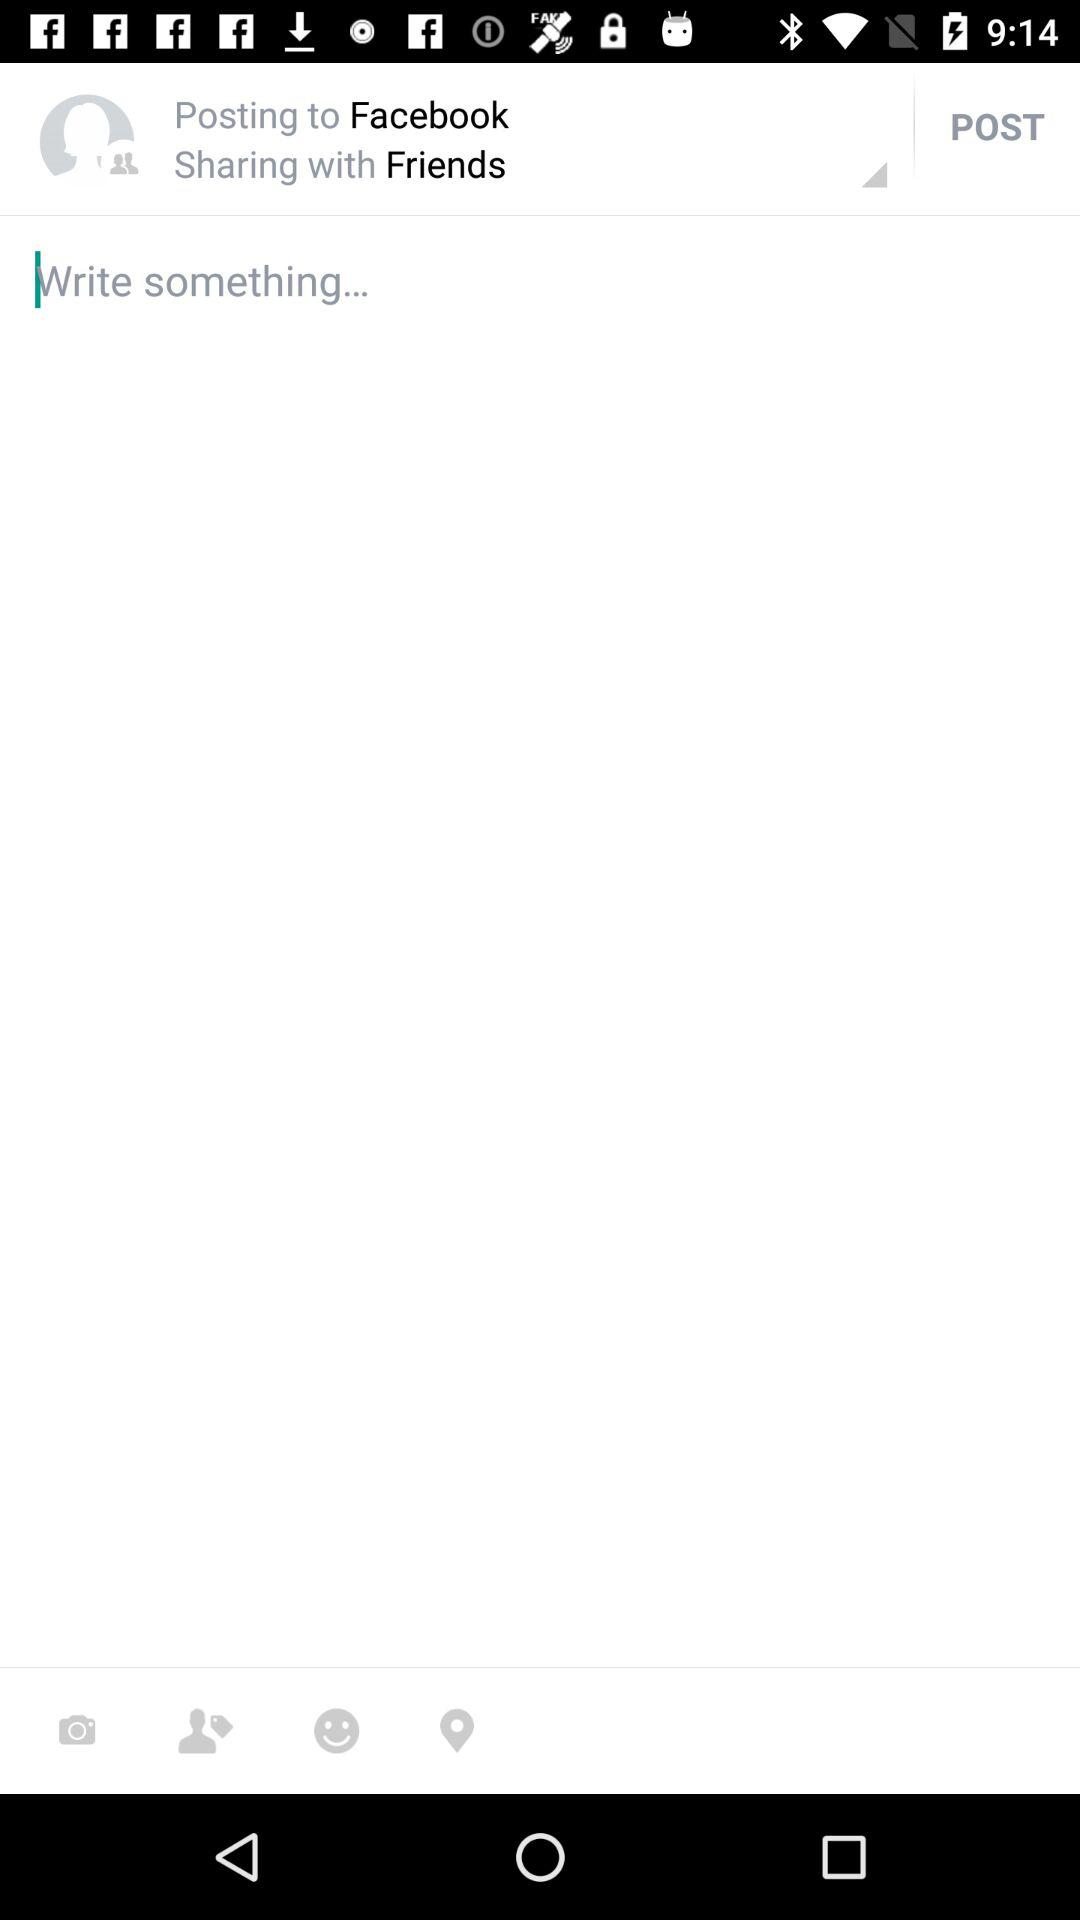Where are we posting the post? You are posting the post to "Facebook". 